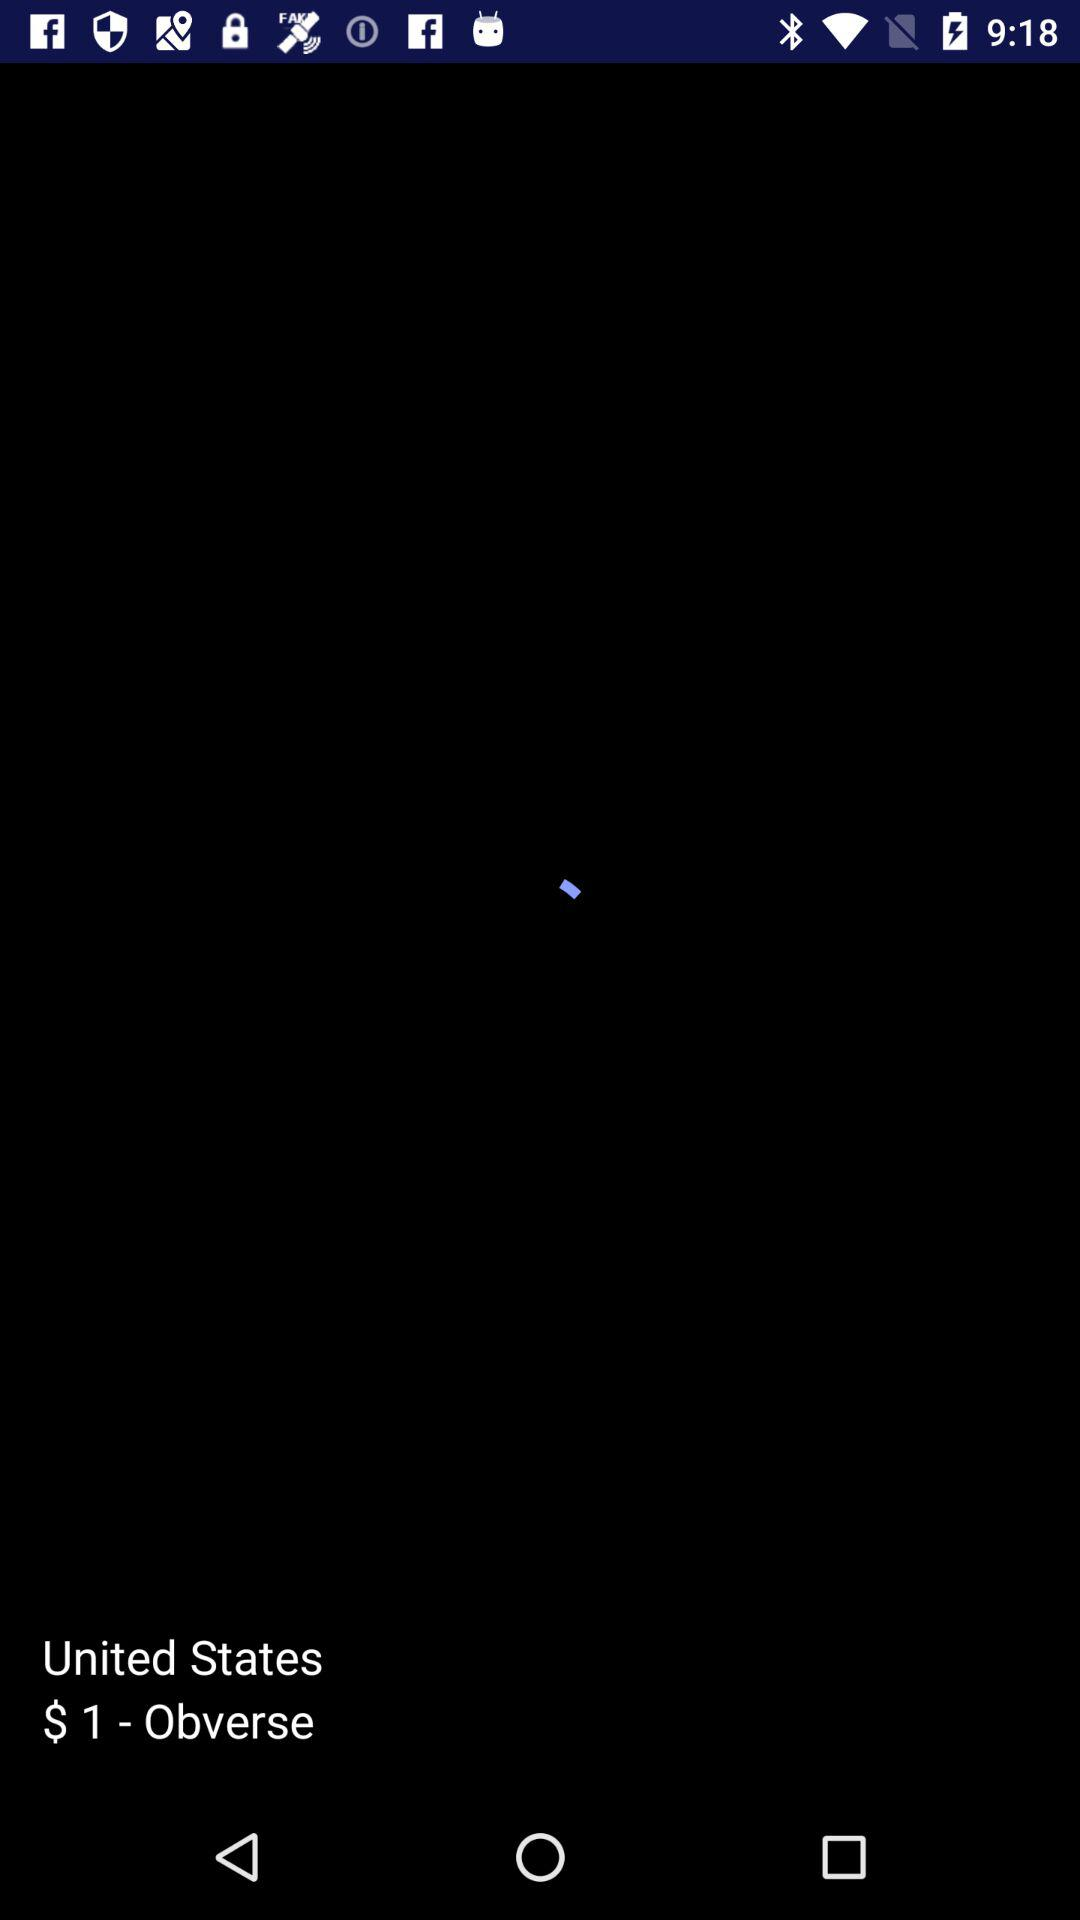What is the country name? The country name is the United States. 